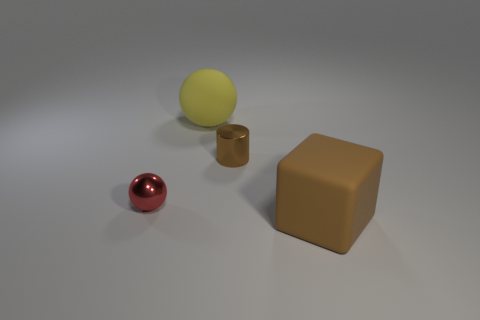Is the number of red metal balls that are right of the tiny brown thing less than the number of matte balls?
Provide a short and direct response. Yes. There is a tiny object that is right of the yellow thing; what material is it?
Offer a very short reply. Metal. How many other objects are the same size as the yellow sphere?
Your answer should be compact. 1. Are there fewer big purple matte spheres than small red metal objects?
Your answer should be very brief. Yes. What is the shape of the brown shiny object?
Your answer should be compact. Cylinder. Does the object that is on the right side of the brown cylinder have the same color as the small cylinder?
Offer a very short reply. Yes. What shape is the thing that is both behind the tiny red metallic object and in front of the rubber sphere?
Provide a succinct answer. Cylinder. There is a thing that is right of the tiny brown object; what is its color?
Keep it short and to the point. Brown. Is there anything else that has the same color as the small sphere?
Ensure brevity in your answer.  No. Is the brown cylinder the same size as the yellow rubber object?
Offer a very short reply. No. 